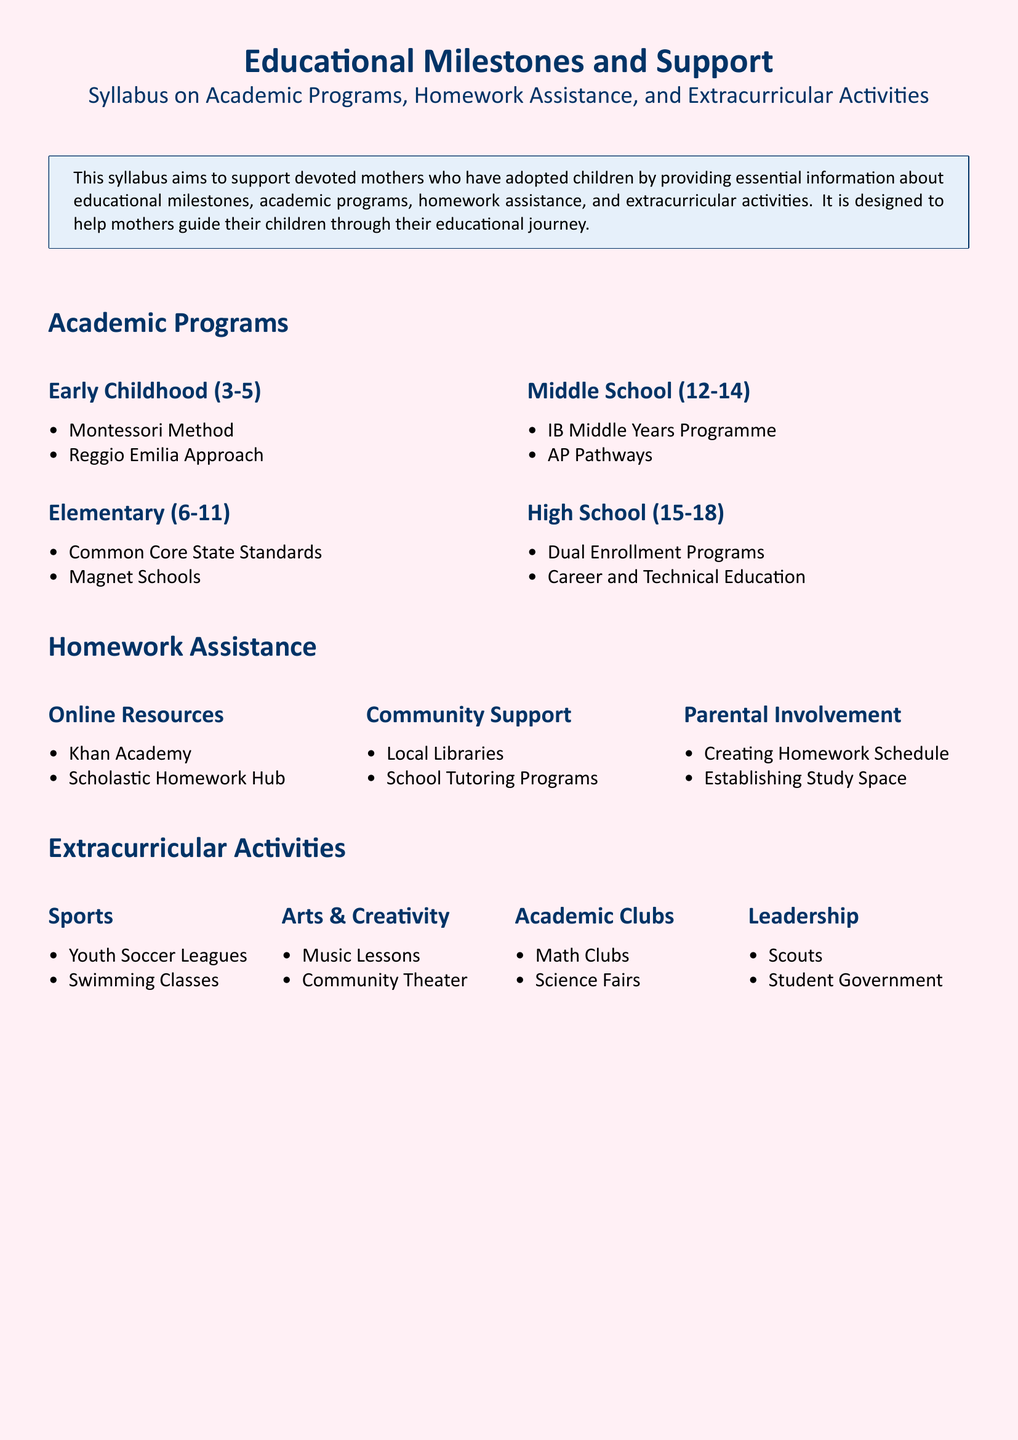What age range does Early Childhood cover? Early Childhood is described to cover ages 3 to 5 in the Academic Programs section.
Answer: 3-5 What academic program is associated with Elementary education? The document lists Common Core State Standards as part of the Elementary academic programs.
Answer: Common Core State Standards Name one online resource for homework assistance. The document mentions Khan Academy under Online Resources for homework assistance.
Answer: Khan Academy What extracurricular activity category includes Math Clubs? The category is Academic Clubs, as listed in the Extracurricular Activities section.
Answer: Academic Clubs How many types of community support are listed for homework assistance? There are two types listed under Community Support in the homework assistance section: Local Libraries and School Tutoring Programs.
Answer: 2 Which educational milestone includes Dual Enrollment Programs? Dual Enrollment Programs are listed under High School in the Academic Programs section.
Answer: High School What type of activity is described under Leadership? The document identifies Scouts and Student Government under the Leadership category in Extracurricular Activities.
Answer: Leadership What is one method mentioned for parental involvement in homework? Creating a Homework Schedule is noted as a method under Parental Involvement.
Answer: Creating Homework Schedule 